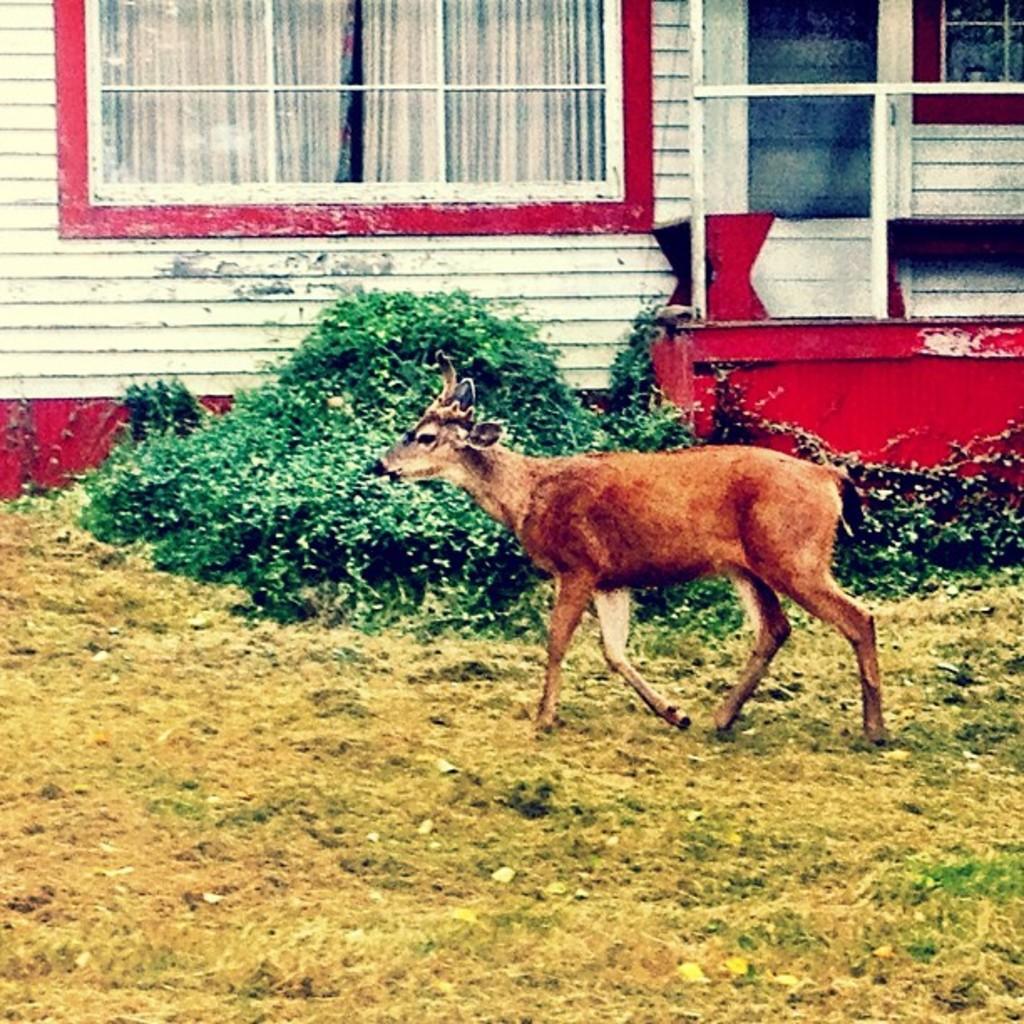How would you summarize this image in a sentence or two? In this picture we can see an animal on the grass and in the background we can see plants, windows, curtains, wall and some objects. 